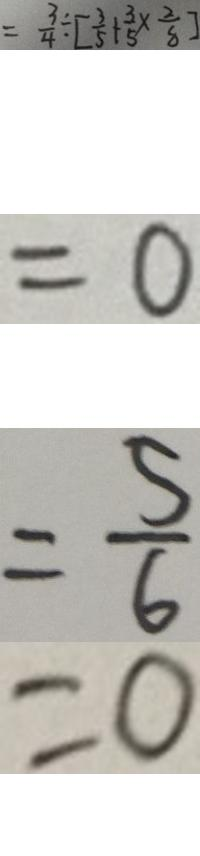Convert formula to latex. <formula><loc_0><loc_0><loc_500><loc_500>= \frac { 3 } { 4 } \div [ \frac { 3 } { 5 } + \frac { 3 } { 5 } \times \frac { 2 } { 8 } ] 
 = 0 
 = \frac { 5 } { 6 } 
 = 0</formula> 